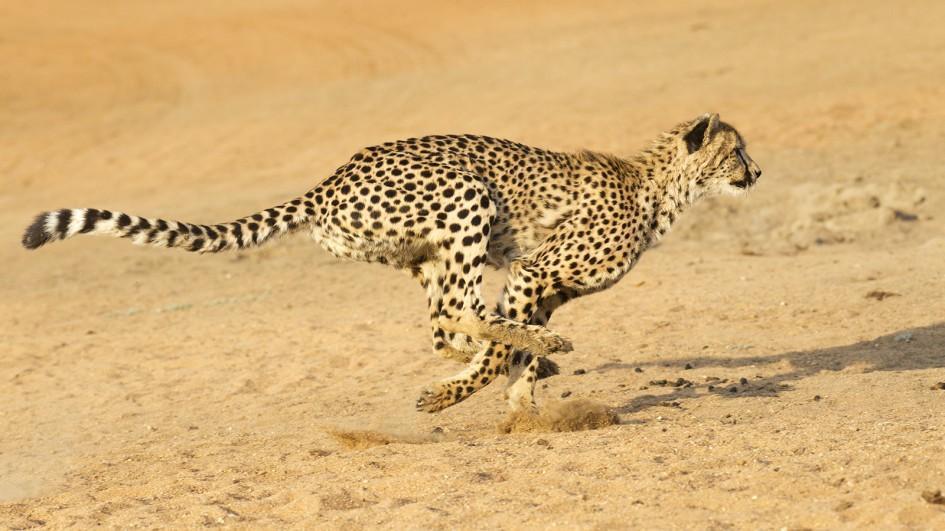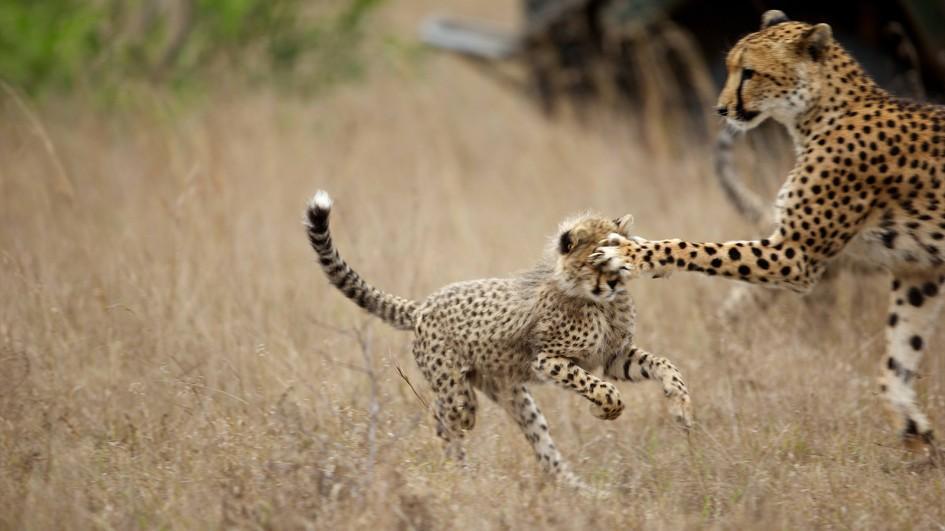The first image is the image on the left, the second image is the image on the right. For the images displayed, is the sentence "A total of five cheetahs are shown between the two images." factually correct? Answer yes or no. No. 